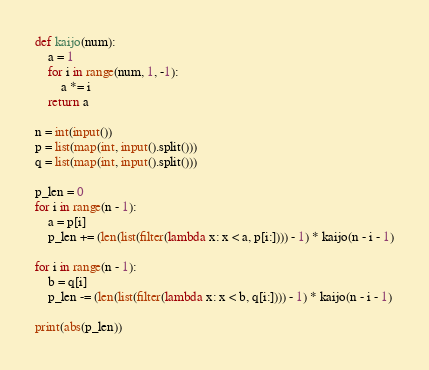Convert code to text. <code><loc_0><loc_0><loc_500><loc_500><_Python_>def kaijo(num):
    a = 1
    for i in range(num, 1, -1):
        a *= i
    return a

n = int(input())
p = list(map(int, input().split()))
q = list(map(int, input().split()))

p_len = 0
for i in range(n - 1):
    a = p[i]
    p_len += (len(list(filter(lambda x: x < a, p[i:]))) - 1) * kaijo(n - i - 1)

for i in range(n - 1):
    b = q[i]
    p_len -= (len(list(filter(lambda x: x < b, q[i:]))) - 1) * kaijo(n - i - 1)

print(abs(p_len))

</code> 